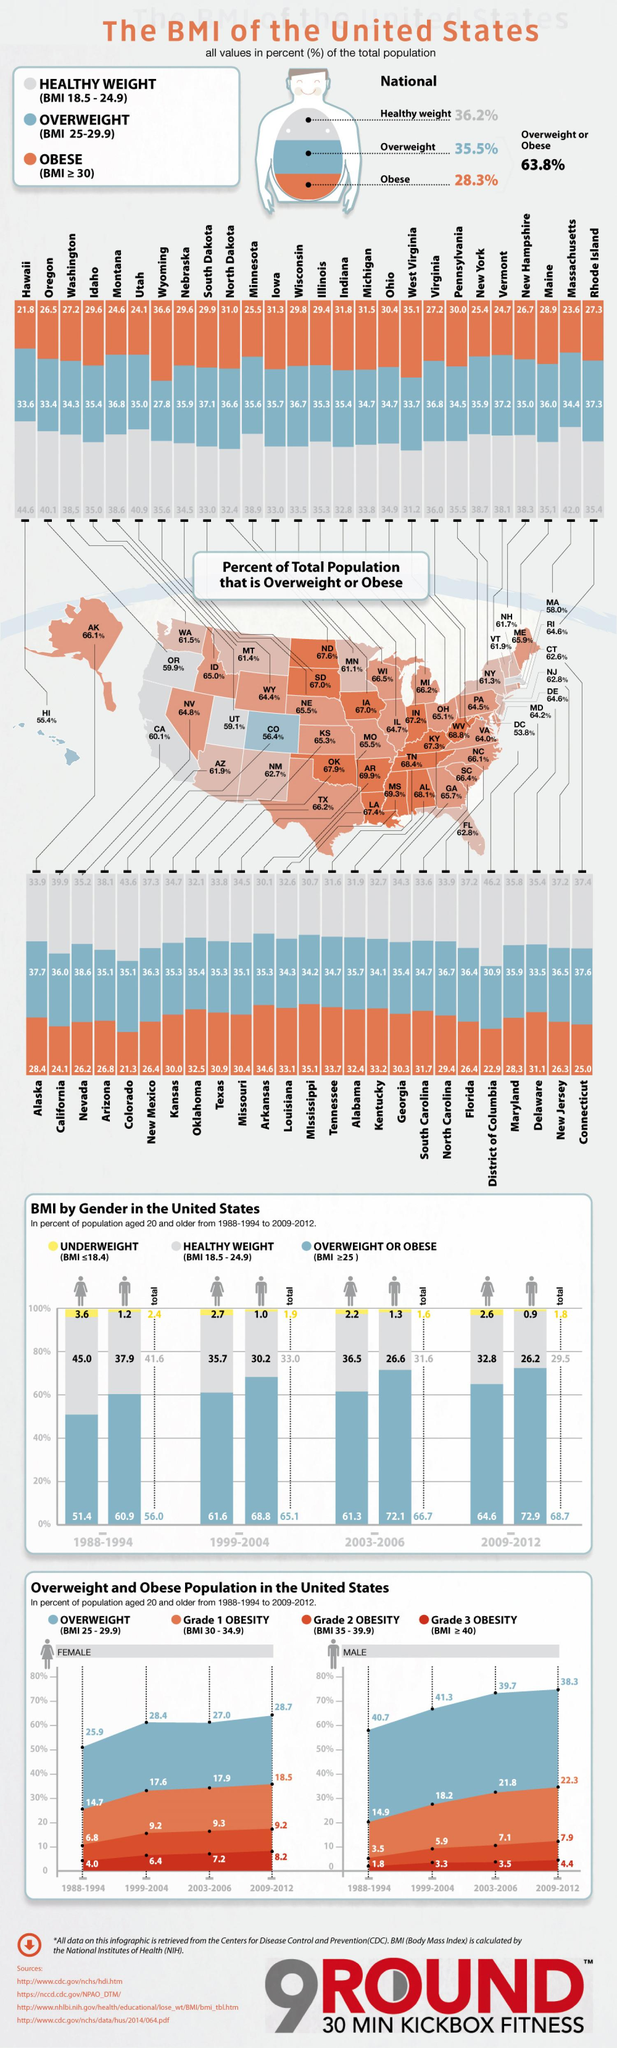Highlight a few significant elements in this photo. In the 1988-1994 period, it was found that 3.6% of women were underweight. In the United States, 28.3% of the total population is obese. This is a significant health concern that requires attention and action. 